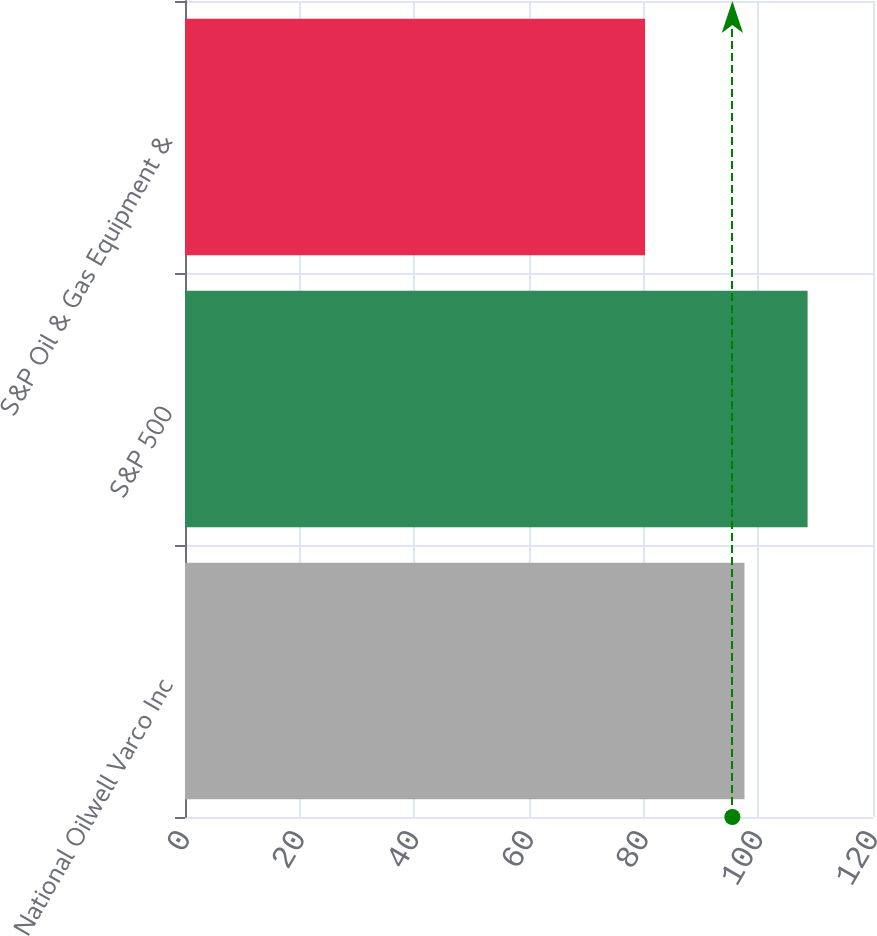Convert chart to OTSL. <chart><loc_0><loc_0><loc_500><loc_500><bar_chart><fcel>National Oilwell Varco Inc<fcel>S&P 500<fcel>S&P Oil & Gas Equipment &<nl><fcel>97.58<fcel>108.59<fcel>80.25<nl></chart> 